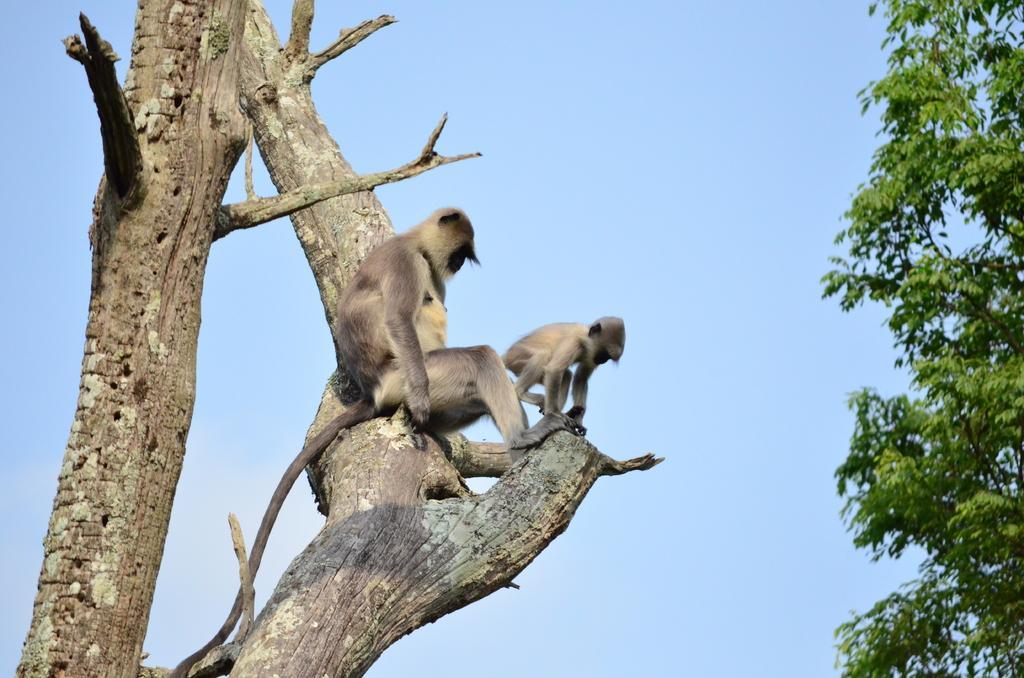Could you give a brief overview of what you see in this image? In this picture we can see 2 monkeys sitting on the branch of a tree surrounded with green leaves and blue sky. 